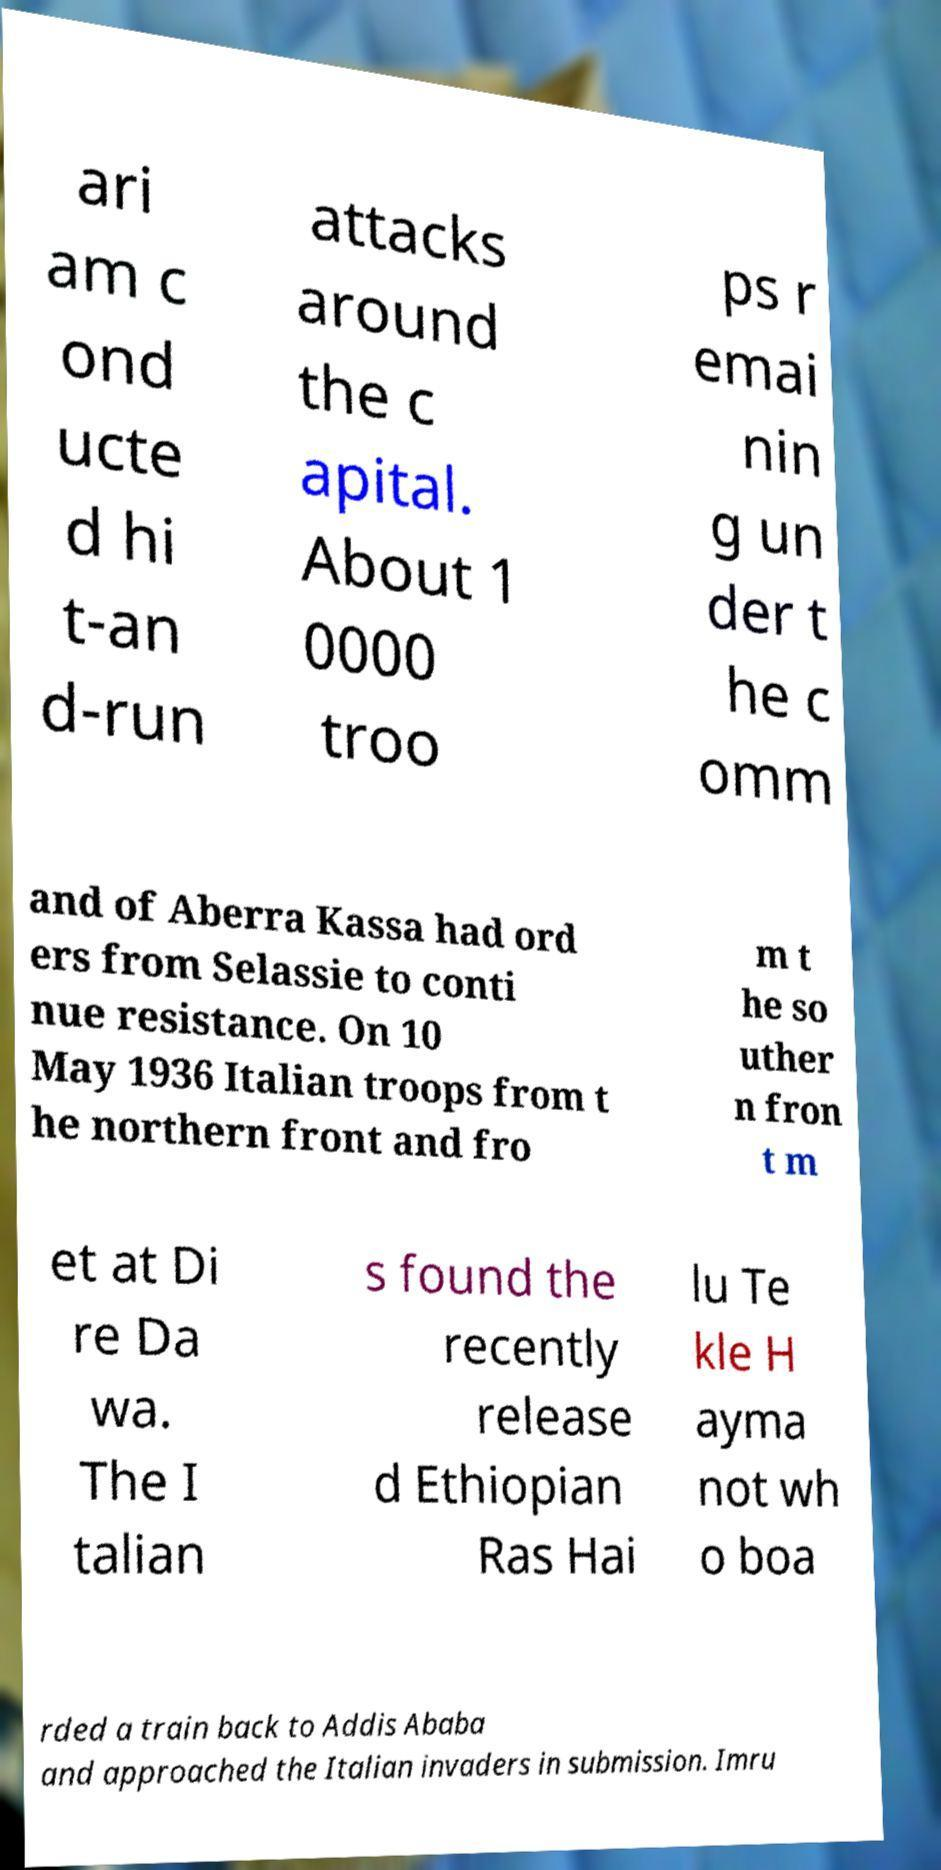Please identify and transcribe the text found in this image. ari am c ond ucte d hi t-an d-run attacks around the c apital. About 1 0000 troo ps r emai nin g un der t he c omm and of Aberra Kassa had ord ers from Selassie to conti nue resistance. On 10 May 1936 Italian troops from t he northern front and fro m t he so uther n fron t m et at Di re Da wa. The I talian s found the recently release d Ethiopian Ras Hai lu Te kle H ayma not wh o boa rded a train back to Addis Ababa and approached the Italian invaders in submission. Imru 